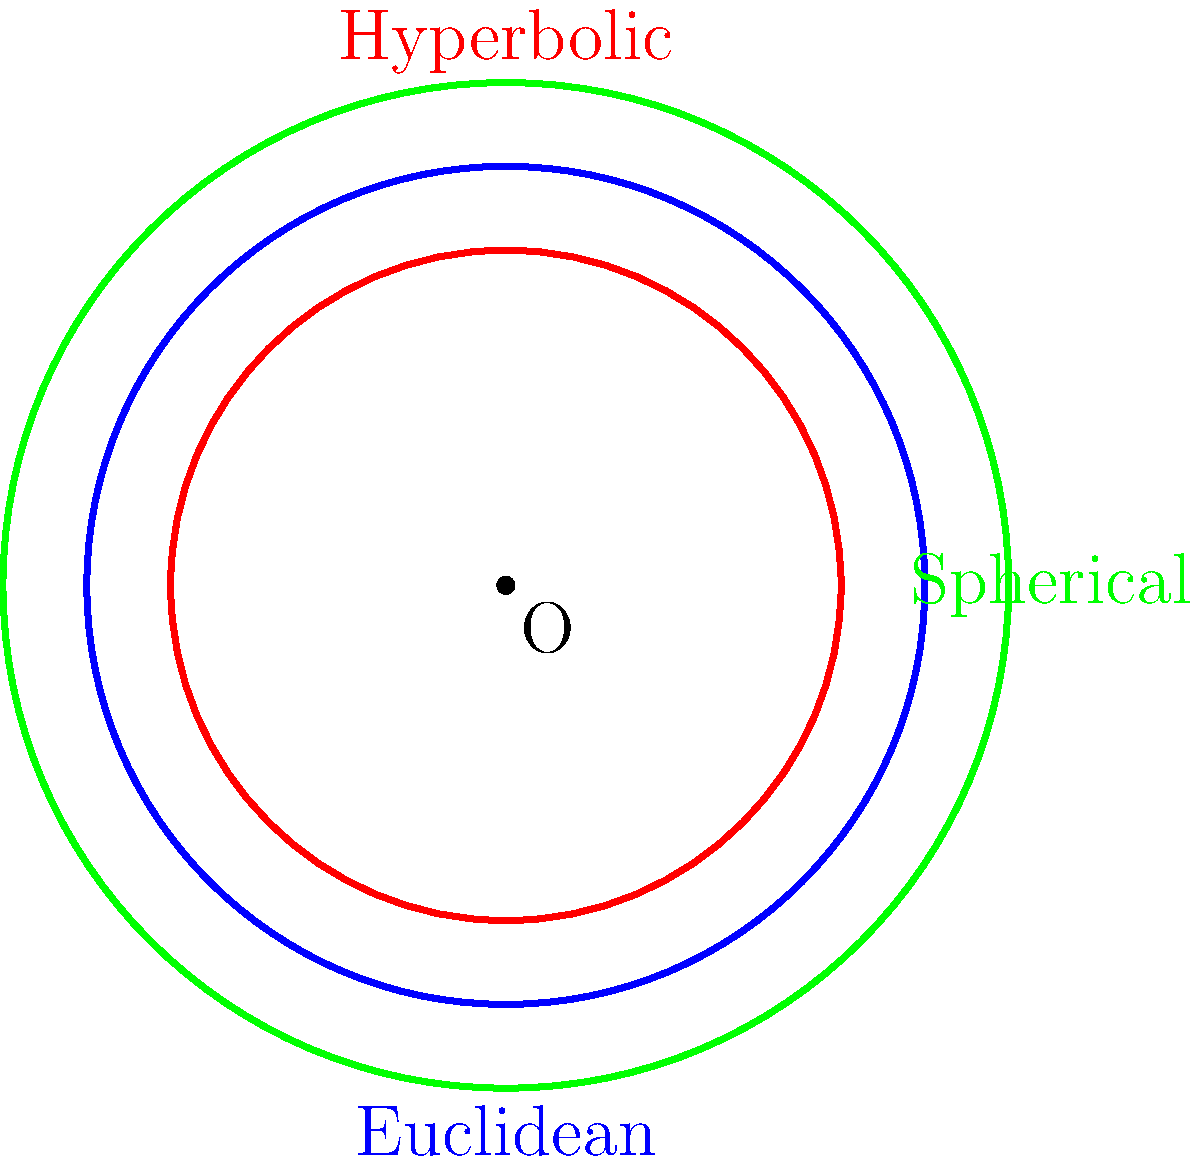In the context of non-Euclidean geometries, which often challenge our conventional understanding of space and social structures, consider the circles shown in the diagram representing Euclidean (blue), hyperbolic (red), and spherical (green) geometries. If all three circles have the same radius when measured within their respective geometries, how do their areas compare? To understand the comparison of circle areas in different geometries, let's break it down step-by-step:

1. Euclidean geometry:
   - In Euclidean space, the area of a circle is given by $A = \pi r^2$.
   - This serves as our baseline for comparison.

2. Hyperbolic geometry:
   - In hyperbolic space, the area of a circle is given by $A = 4\pi \sinh^2(\frac{r}{2})$, where $\sinh$ is the hyperbolic sine function.
   - For small radii, this is approximately equal to the Euclidean formula.
   - As the radius increases, the area grows exponentially faster than in Euclidean space.

3. Spherical geometry:
   - In spherical space, the area of a circle is given by $A = 2\pi R^2(1 - \cos(\frac{r}{R}))$, where $R$ is the radius of the sphere.
   - For small radii, this is approximately equal to the Euclidean formula.
   - As the radius increases, the area grows more slowly than in Euclidean space, eventually reaching a maximum of $4\pi R^2$ (the surface area of the sphere) when the circle becomes a great circle.

4. Comparison:
   - For very small radii, all three geometries yield approximately the same area.
   - As the radius increases:
     * The hyperbolic circle's area grows fastest.
     * The Euclidean circle's area grows at a constant rate (quadratic).
     * The spherical circle's area grows slowest, eventually plateauing.

Therefore, for circles with the same radius in their respective geometries:

Hyperbolic area > Euclidean area > Spherical area

This comparison reflects how different geometric models can represent diverse social structures and spatial relationships, which is relevant to understanding the impact of spatial concepts on political and social organization throughout US history.
Answer: Hyperbolic > Euclidean > Spherical 